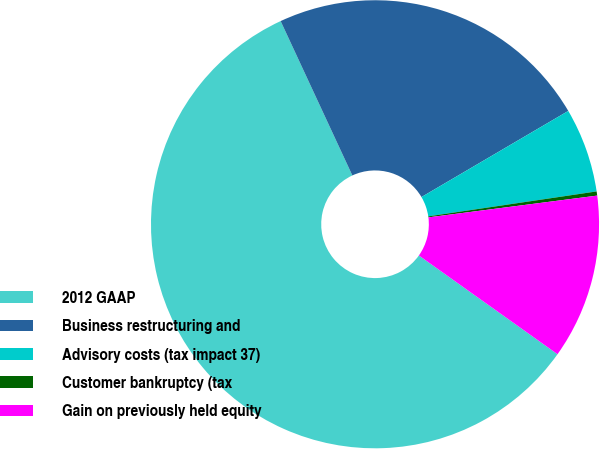Convert chart. <chart><loc_0><loc_0><loc_500><loc_500><pie_chart><fcel>2012 GAAP<fcel>Business restructuring and<fcel>Advisory costs (tax impact 37)<fcel>Customer bankruptcy (tax<fcel>Gain on previously held equity<nl><fcel>58.23%<fcel>23.48%<fcel>6.1%<fcel>0.3%<fcel>11.89%<nl></chart> 